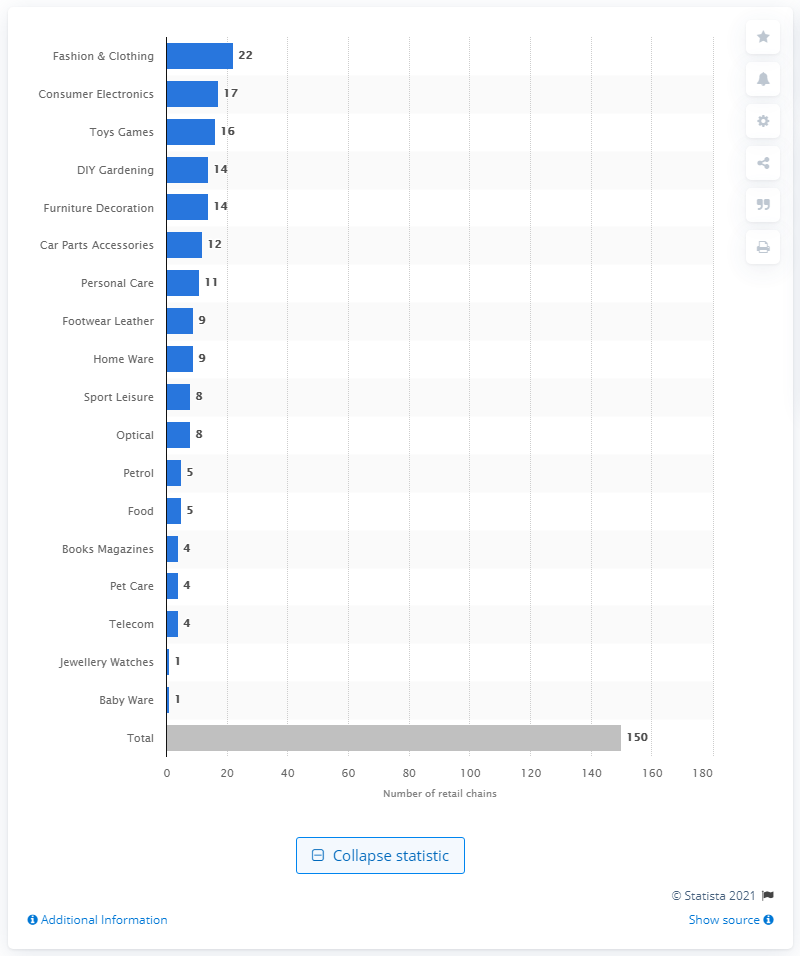Mention a couple of crucial points in this snapshot. In 2016, the toys and games retail sector in Norway had 16 chains. In 2016, there were approximately 150 retail chains in Norway. In 2016, consumer electronics were accounted for by 17 retail chains. There were 22 retail chains in the fashion and clothing industry in Norway in 2016. 